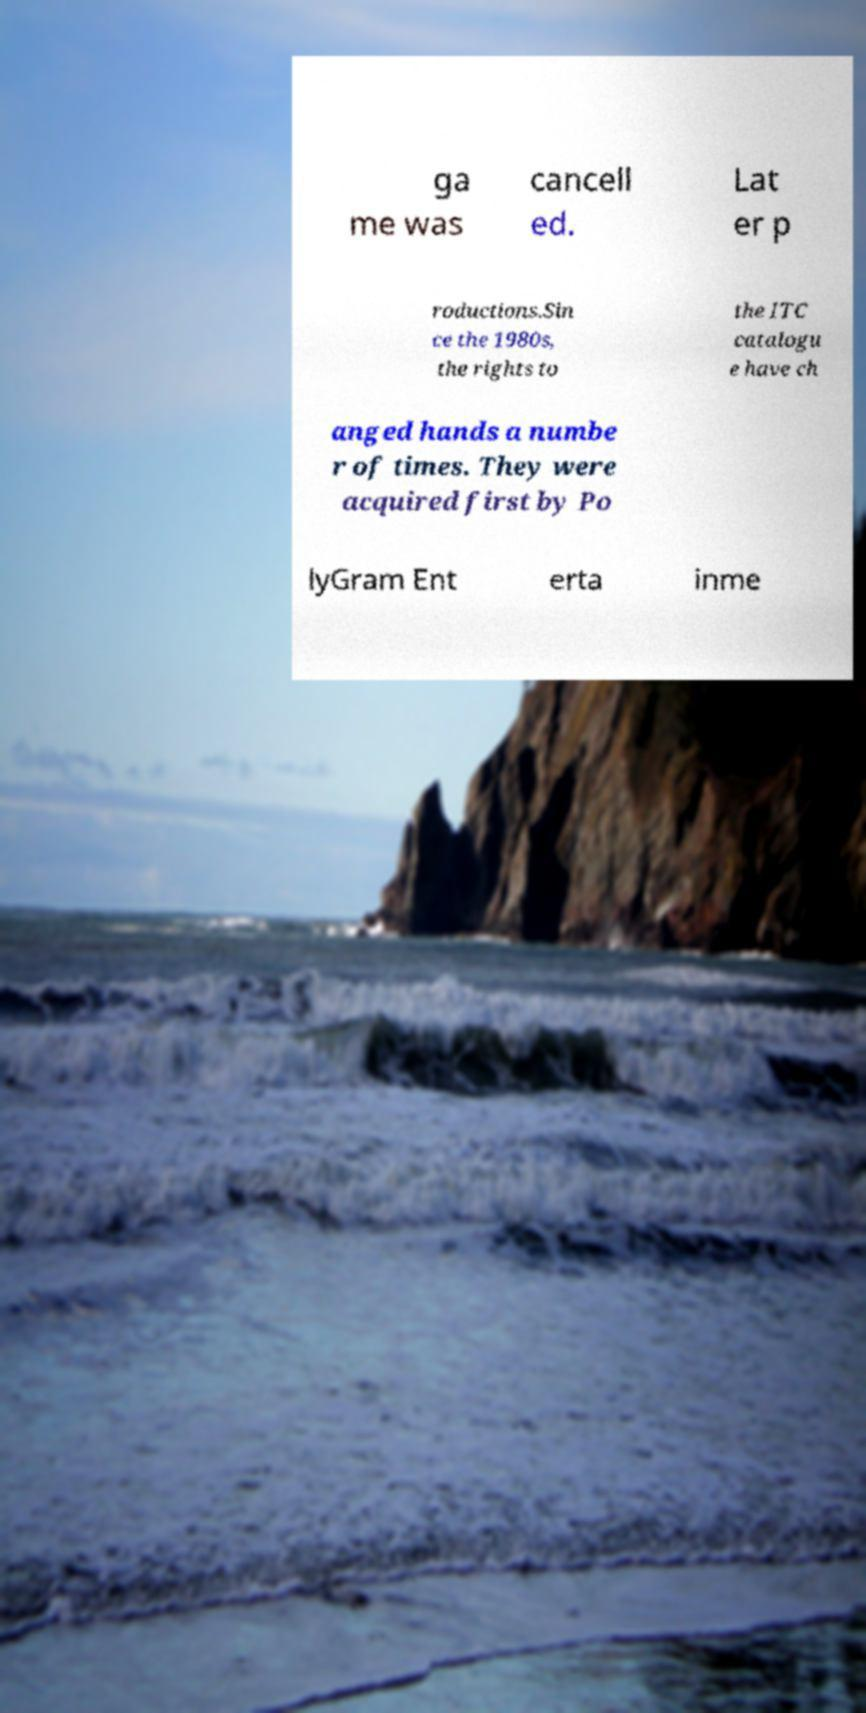Please identify and transcribe the text found in this image. ga me was cancell ed. Lat er p roductions.Sin ce the 1980s, the rights to the ITC catalogu e have ch anged hands a numbe r of times. They were acquired first by Po lyGram Ent erta inme 